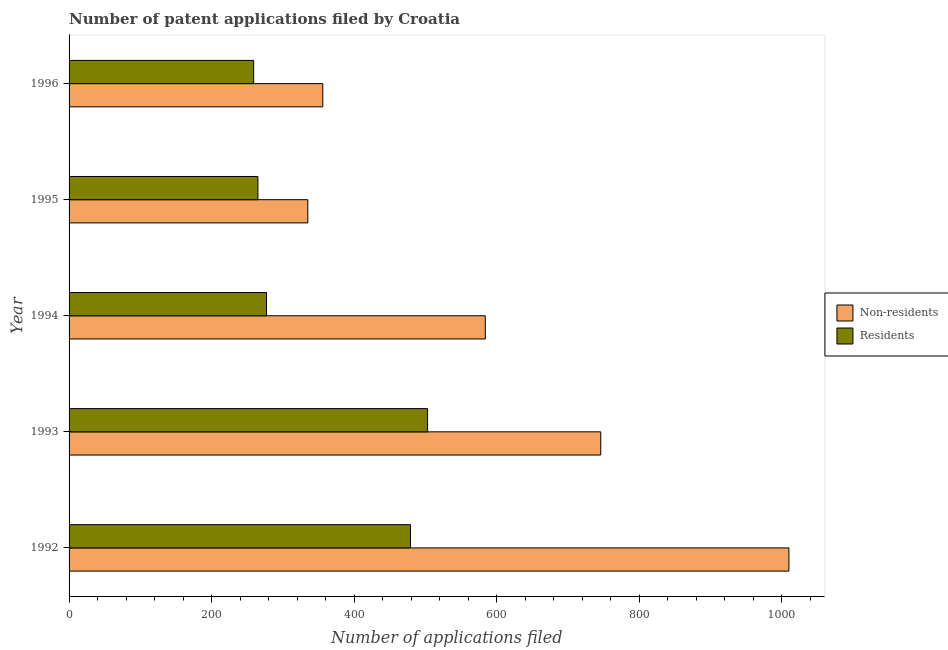How many groups of bars are there?
Ensure brevity in your answer.  5. Are the number of bars per tick equal to the number of legend labels?
Keep it short and to the point. Yes. What is the label of the 2nd group of bars from the top?
Make the answer very short. 1995. In how many cases, is the number of bars for a given year not equal to the number of legend labels?
Your answer should be very brief. 0. What is the number of patent applications by residents in 1993?
Provide a succinct answer. 503. Across all years, what is the maximum number of patent applications by non residents?
Make the answer very short. 1010. Across all years, what is the minimum number of patent applications by non residents?
Offer a terse response. 335. In which year was the number of patent applications by non residents minimum?
Your response must be concise. 1995. What is the total number of patent applications by residents in the graph?
Offer a terse response. 1783. What is the difference between the number of patent applications by residents in 1992 and that in 1994?
Offer a very short reply. 202. What is the difference between the number of patent applications by non residents in 1995 and the number of patent applications by residents in 1993?
Your response must be concise. -168. What is the average number of patent applications by non residents per year?
Your answer should be compact. 606.2. In the year 1996, what is the difference between the number of patent applications by residents and number of patent applications by non residents?
Provide a short and direct response. -97. What is the ratio of the number of patent applications by residents in 1992 to that in 1996?
Offer a very short reply. 1.85. Is the number of patent applications by non residents in 1994 less than that in 1995?
Make the answer very short. No. Is the difference between the number of patent applications by non residents in 1993 and 1994 greater than the difference between the number of patent applications by residents in 1993 and 1994?
Provide a short and direct response. No. What is the difference between the highest and the second highest number of patent applications by non residents?
Give a very brief answer. 264. What is the difference between the highest and the lowest number of patent applications by non residents?
Make the answer very short. 675. In how many years, is the number of patent applications by residents greater than the average number of patent applications by residents taken over all years?
Give a very brief answer. 2. What does the 2nd bar from the top in 1993 represents?
Make the answer very short. Non-residents. What does the 2nd bar from the bottom in 1992 represents?
Your answer should be compact. Residents. How many years are there in the graph?
Your response must be concise. 5. What is the difference between two consecutive major ticks on the X-axis?
Your answer should be compact. 200. Are the values on the major ticks of X-axis written in scientific E-notation?
Offer a terse response. No. Where does the legend appear in the graph?
Offer a terse response. Center right. How many legend labels are there?
Give a very brief answer. 2. What is the title of the graph?
Give a very brief answer. Number of patent applications filed by Croatia. Does "Register a property" appear as one of the legend labels in the graph?
Offer a very short reply. No. What is the label or title of the X-axis?
Make the answer very short. Number of applications filed. What is the Number of applications filed in Non-residents in 1992?
Provide a succinct answer. 1010. What is the Number of applications filed in Residents in 1992?
Ensure brevity in your answer.  479. What is the Number of applications filed of Non-residents in 1993?
Keep it short and to the point. 746. What is the Number of applications filed in Residents in 1993?
Make the answer very short. 503. What is the Number of applications filed of Non-residents in 1994?
Provide a succinct answer. 584. What is the Number of applications filed of Residents in 1994?
Offer a terse response. 277. What is the Number of applications filed of Non-residents in 1995?
Your answer should be very brief. 335. What is the Number of applications filed in Residents in 1995?
Make the answer very short. 265. What is the Number of applications filed in Non-residents in 1996?
Give a very brief answer. 356. What is the Number of applications filed in Residents in 1996?
Your response must be concise. 259. Across all years, what is the maximum Number of applications filed of Non-residents?
Make the answer very short. 1010. Across all years, what is the maximum Number of applications filed in Residents?
Keep it short and to the point. 503. Across all years, what is the minimum Number of applications filed of Non-residents?
Offer a very short reply. 335. Across all years, what is the minimum Number of applications filed in Residents?
Offer a terse response. 259. What is the total Number of applications filed in Non-residents in the graph?
Offer a terse response. 3031. What is the total Number of applications filed in Residents in the graph?
Ensure brevity in your answer.  1783. What is the difference between the Number of applications filed in Non-residents in 1992 and that in 1993?
Provide a short and direct response. 264. What is the difference between the Number of applications filed of Residents in 1992 and that in 1993?
Your answer should be very brief. -24. What is the difference between the Number of applications filed in Non-residents in 1992 and that in 1994?
Your answer should be compact. 426. What is the difference between the Number of applications filed of Residents in 1992 and that in 1994?
Offer a terse response. 202. What is the difference between the Number of applications filed of Non-residents in 1992 and that in 1995?
Offer a terse response. 675. What is the difference between the Number of applications filed in Residents in 1992 and that in 1995?
Provide a succinct answer. 214. What is the difference between the Number of applications filed of Non-residents in 1992 and that in 1996?
Your answer should be compact. 654. What is the difference between the Number of applications filed in Residents in 1992 and that in 1996?
Give a very brief answer. 220. What is the difference between the Number of applications filed of Non-residents in 1993 and that in 1994?
Provide a short and direct response. 162. What is the difference between the Number of applications filed of Residents in 1993 and that in 1994?
Ensure brevity in your answer.  226. What is the difference between the Number of applications filed in Non-residents in 1993 and that in 1995?
Give a very brief answer. 411. What is the difference between the Number of applications filed of Residents in 1993 and that in 1995?
Offer a terse response. 238. What is the difference between the Number of applications filed in Non-residents in 1993 and that in 1996?
Offer a terse response. 390. What is the difference between the Number of applications filed in Residents in 1993 and that in 1996?
Provide a short and direct response. 244. What is the difference between the Number of applications filed in Non-residents in 1994 and that in 1995?
Offer a terse response. 249. What is the difference between the Number of applications filed in Non-residents in 1994 and that in 1996?
Make the answer very short. 228. What is the difference between the Number of applications filed in Non-residents in 1995 and that in 1996?
Offer a terse response. -21. What is the difference between the Number of applications filed of Residents in 1995 and that in 1996?
Keep it short and to the point. 6. What is the difference between the Number of applications filed of Non-residents in 1992 and the Number of applications filed of Residents in 1993?
Ensure brevity in your answer.  507. What is the difference between the Number of applications filed of Non-residents in 1992 and the Number of applications filed of Residents in 1994?
Offer a very short reply. 733. What is the difference between the Number of applications filed in Non-residents in 1992 and the Number of applications filed in Residents in 1995?
Provide a succinct answer. 745. What is the difference between the Number of applications filed in Non-residents in 1992 and the Number of applications filed in Residents in 1996?
Your response must be concise. 751. What is the difference between the Number of applications filed in Non-residents in 1993 and the Number of applications filed in Residents in 1994?
Your answer should be very brief. 469. What is the difference between the Number of applications filed of Non-residents in 1993 and the Number of applications filed of Residents in 1995?
Your answer should be compact. 481. What is the difference between the Number of applications filed of Non-residents in 1993 and the Number of applications filed of Residents in 1996?
Your answer should be very brief. 487. What is the difference between the Number of applications filed in Non-residents in 1994 and the Number of applications filed in Residents in 1995?
Your response must be concise. 319. What is the difference between the Number of applications filed in Non-residents in 1994 and the Number of applications filed in Residents in 1996?
Your response must be concise. 325. What is the average Number of applications filed of Non-residents per year?
Offer a terse response. 606.2. What is the average Number of applications filed of Residents per year?
Offer a terse response. 356.6. In the year 1992, what is the difference between the Number of applications filed of Non-residents and Number of applications filed of Residents?
Keep it short and to the point. 531. In the year 1993, what is the difference between the Number of applications filed of Non-residents and Number of applications filed of Residents?
Your answer should be compact. 243. In the year 1994, what is the difference between the Number of applications filed in Non-residents and Number of applications filed in Residents?
Give a very brief answer. 307. In the year 1995, what is the difference between the Number of applications filed in Non-residents and Number of applications filed in Residents?
Ensure brevity in your answer.  70. In the year 1996, what is the difference between the Number of applications filed of Non-residents and Number of applications filed of Residents?
Offer a terse response. 97. What is the ratio of the Number of applications filed in Non-residents in 1992 to that in 1993?
Keep it short and to the point. 1.35. What is the ratio of the Number of applications filed in Residents in 1992 to that in 1993?
Your answer should be compact. 0.95. What is the ratio of the Number of applications filed of Non-residents in 1992 to that in 1994?
Provide a short and direct response. 1.73. What is the ratio of the Number of applications filed in Residents in 1992 to that in 1994?
Ensure brevity in your answer.  1.73. What is the ratio of the Number of applications filed in Non-residents in 1992 to that in 1995?
Make the answer very short. 3.01. What is the ratio of the Number of applications filed in Residents in 1992 to that in 1995?
Offer a very short reply. 1.81. What is the ratio of the Number of applications filed in Non-residents in 1992 to that in 1996?
Provide a succinct answer. 2.84. What is the ratio of the Number of applications filed of Residents in 1992 to that in 1996?
Keep it short and to the point. 1.85. What is the ratio of the Number of applications filed of Non-residents in 1993 to that in 1994?
Provide a short and direct response. 1.28. What is the ratio of the Number of applications filed of Residents in 1993 to that in 1994?
Provide a succinct answer. 1.82. What is the ratio of the Number of applications filed in Non-residents in 1993 to that in 1995?
Ensure brevity in your answer.  2.23. What is the ratio of the Number of applications filed in Residents in 1993 to that in 1995?
Offer a terse response. 1.9. What is the ratio of the Number of applications filed of Non-residents in 1993 to that in 1996?
Provide a succinct answer. 2.1. What is the ratio of the Number of applications filed in Residents in 1993 to that in 1996?
Your answer should be compact. 1.94. What is the ratio of the Number of applications filed of Non-residents in 1994 to that in 1995?
Your answer should be very brief. 1.74. What is the ratio of the Number of applications filed of Residents in 1994 to that in 1995?
Provide a succinct answer. 1.05. What is the ratio of the Number of applications filed of Non-residents in 1994 to that in 1996?
Your answer should be compact. 1.64. What is the ratio of the Number of applications filed in Residents in 1994 to that in 1996?
Keep it short and to the point. 1.07. What is the ratio of the Number of applications filed of Non-residents in 1995 to that in 1996?
Your answer should be very brief. 0.94. What is the ratio of the Number of applications filed in Residents in 1995 to that in 1996?
Your answer should be compact. 1.02. What is the difference between the highest and the second highest Number of applications filed of Non-residents?
Your response must be concise. 264. What is the difference between the highest and the lowest Number of applications filed of Non-residents?
Ensure brevity in your answer.  675. What is the difference between the highest and the lowest Number of applications filed in Residents?
Your answer should be compact. 244. 